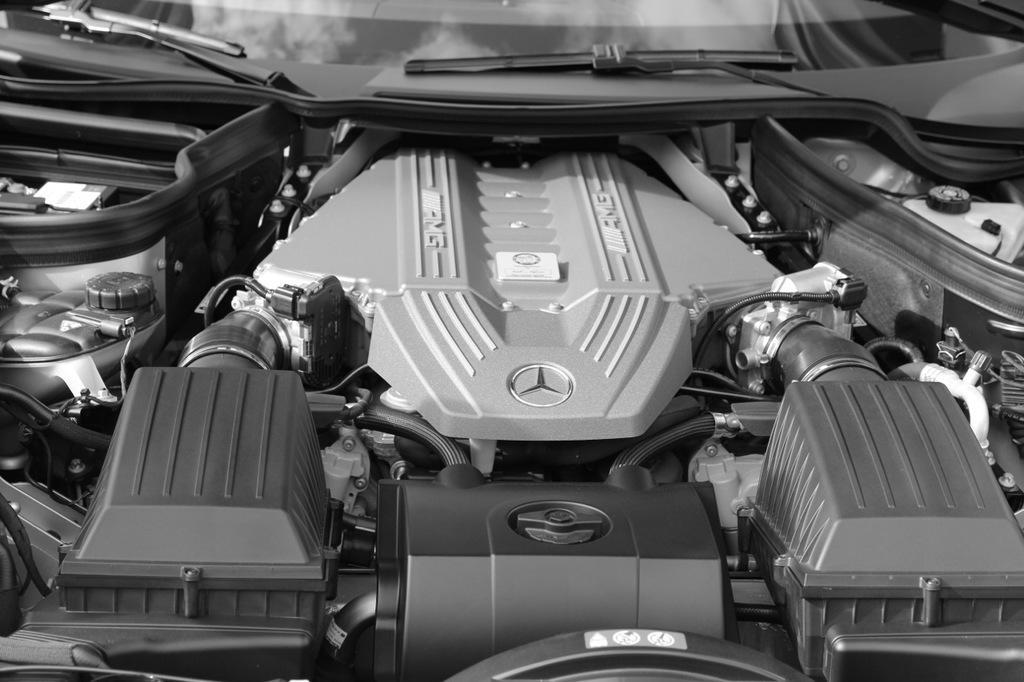Please provide a concise description of this image. In this image I can see a car and its parts. This image is taken during a day may be on the road. 